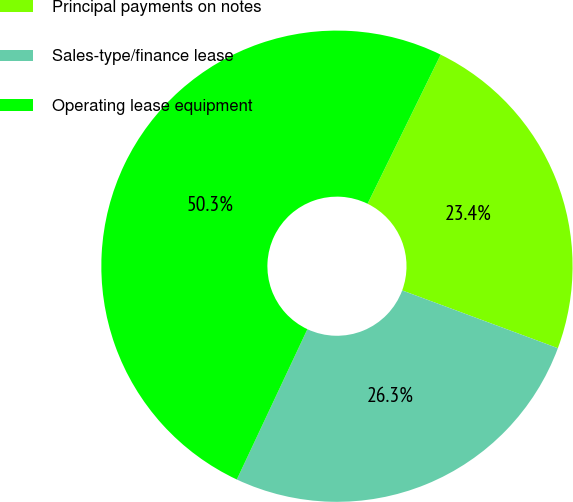Convert chart. <chart><loc_0><loc_0><loc_500><loc_500><pie_chart><fcel>Principal payments on notes<fcel>Sales-type/finance lease<fcel>Operating lease equipment<nl><fcel>23.4%<fcel>26.33%<fcel>50.27%<nl></chart> 